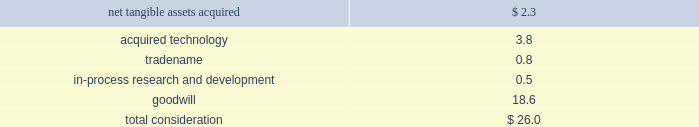Notes to consolidated financial statements ( continued ) note 4 2014acquisitions ( continued ) acquisition of emagic gmbh during the fourth quarter of 2002 , the company acquired emagic gmbh ( emagic ) , a provider of professional software solutions for computer based music production , for approximately $ 30 million in cash ; $ 26 million of which was paid immediately upon closing of the deal and $ 4 million of which was held-back for future payment contingent on continued employment by certain employees that would be allocated to future compensation expense in the appropriate periods over the following 3 years .
During fiscal 2003 , contingent consideration totaling $ 1.3 million was paid .
The acquisition has been accounted for as a purchase .
The portion of the purchase price allocated to purchased in-process research and development ( ipr&d ) was expensed immediately , and the portion of the purchase price allocated to acquired technology and to tradename will be amortized over their estimated useful lives of 3 years .
Goodwill associated with the acquisition of emagic is not subject to amortization pursuant to the provisions of sfas no .
142 .
Total consideration was allocated as follows ( in millions ) : .
The amount of the purchase price allocated to ipr&d was expensed upon acquisition , because the technological feasibility of products under development had not been established and no alternative future uses existed .
The ipr&d relates primarily to emagic 2019s logic series technology and extensions .
At the date of the acquisition , the products under development were between 43%-83% ( 43%-83 % ) complete , and it was expected that the remaining work would be completed during the company 2019s fiscal 2003 at a cost of approximately $ 415000 .
The remaining efforts , which were completed in 2003 , included finalizing user interface design and development , and testing .
The fair value of the ipr&d was determined using an income approach , which reflects the projected free cash flows that will be generated by the ipr&d projects and that are attributable to the acquired technology , and discounting the projected net cash flows back to their present value using a discount rate of 25% ( 25 % ) .
Acquisition of certain assets of zayante , inc. , prismo graphics , and silicon grail during fiscal 2002 the company acquired certain technology and patent rights of zayante , inc. , prismo graphics , and silicon grail corporation for a total of $ 20 million in cash .
These transactions have been accounted for as asset acquisitions .
The purchase price for these asset acquisitions , except for $ 1 million identified as contingent consideration which would be allocated to compensation expense over the following 3 years , has been allocated to acquired technology and would be amortized on a straight-line basis over 3 years , except for certain assets acquired from zayante associated with patent royalty streams that would be amortized over 10 years .
Acquisition of nothing real , llc during the second quarter of 2002 , the company acquired certain assets of nothing real , llc ( nothing real ) , a privately-held company that develops and markets high performance tools designed for the digital image creation market .
Of the $ 15 million purchase price , the company has allocated $ 7 million to acquired technology , which will be amortized over its estimated life of 5 years .
The remaining $ 8 million , which has been identified as contingent consideration , rather than recorded as an additional component of .
During the fourth quarter of 2002 , the company acquired emagic gmbh ( emagic ) , a provider of professional software solutions for computer based music production , for approximately $ 30 million in cash . what percentage of the purchase price was paid immediately upon closing of the deal? 
Computations: (26.0 / 30)
Answer: 0.86667. 